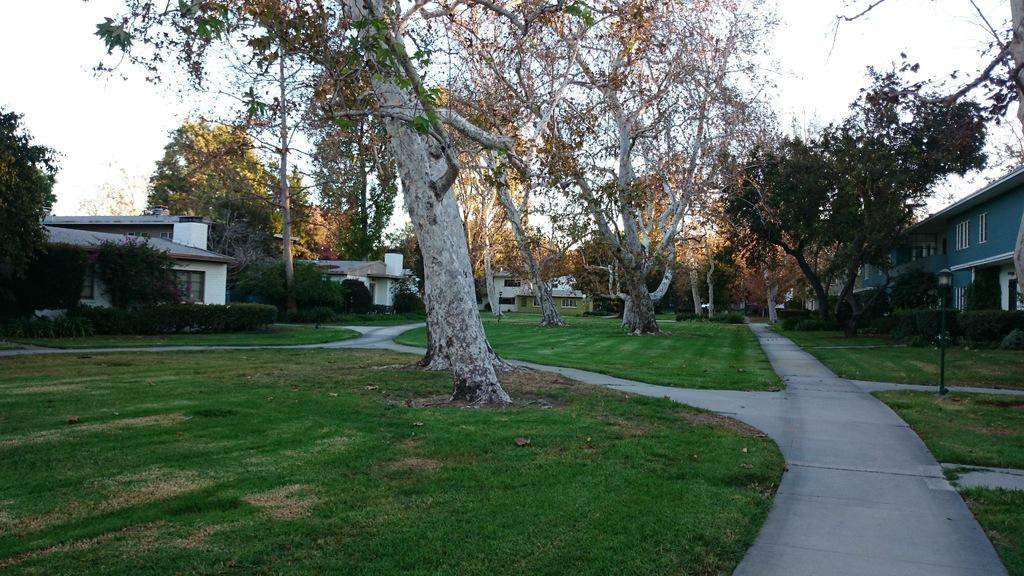What type of vegetation can be seen in the foreground of the image? There is grass, plants, and trees in the foreground of the image. What structures are present in the foreground of the image? There are light poles and houses in the foreground of the image. What can be seen in the background of the image? The sky is visible in the background of the image. Can you determine the time of day the image was taken? The image was likely taken during the day, as the sky is visible and there is no indication of darkness. What grade is the tail of the dog in the image? There is no dog present in the image, so it is not possible to determine the grade of its tail. 